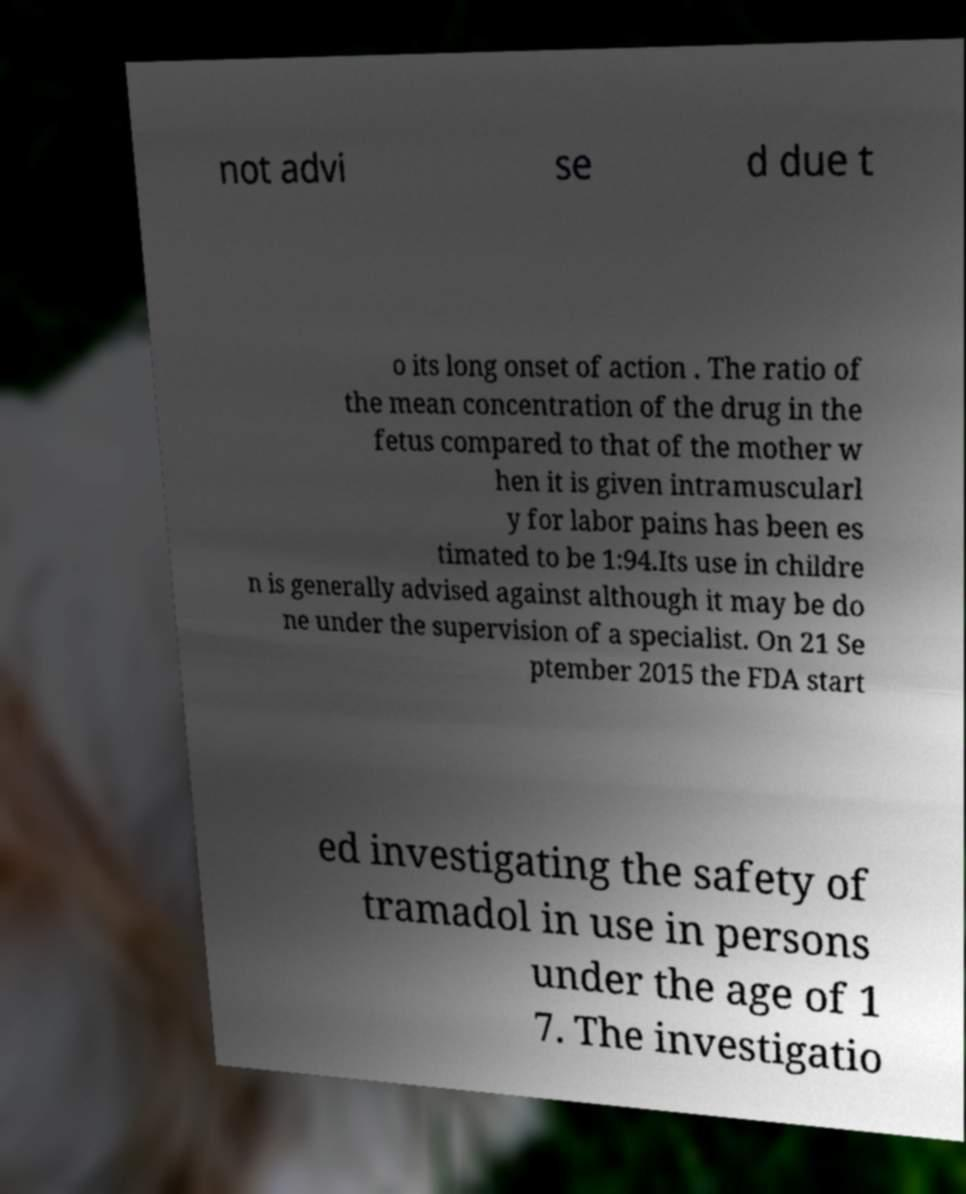What messages or text are displayed in this image? I need them in a readable, typed format. not advi se d due t o its long onset of action . The ratio of the mean concentration of the drug in the fetus compared to that of the mother w hen it is given intramuscularl y for labor pains has been es timated to be 1:94.Its use in childre n is generally advised against although it may be do ne under the supervision of a specialist. On 21 Se ptember 2015 the FDA start ed investigating the safety of tramadol in use in persons under the age of 1 7. The investigatio 